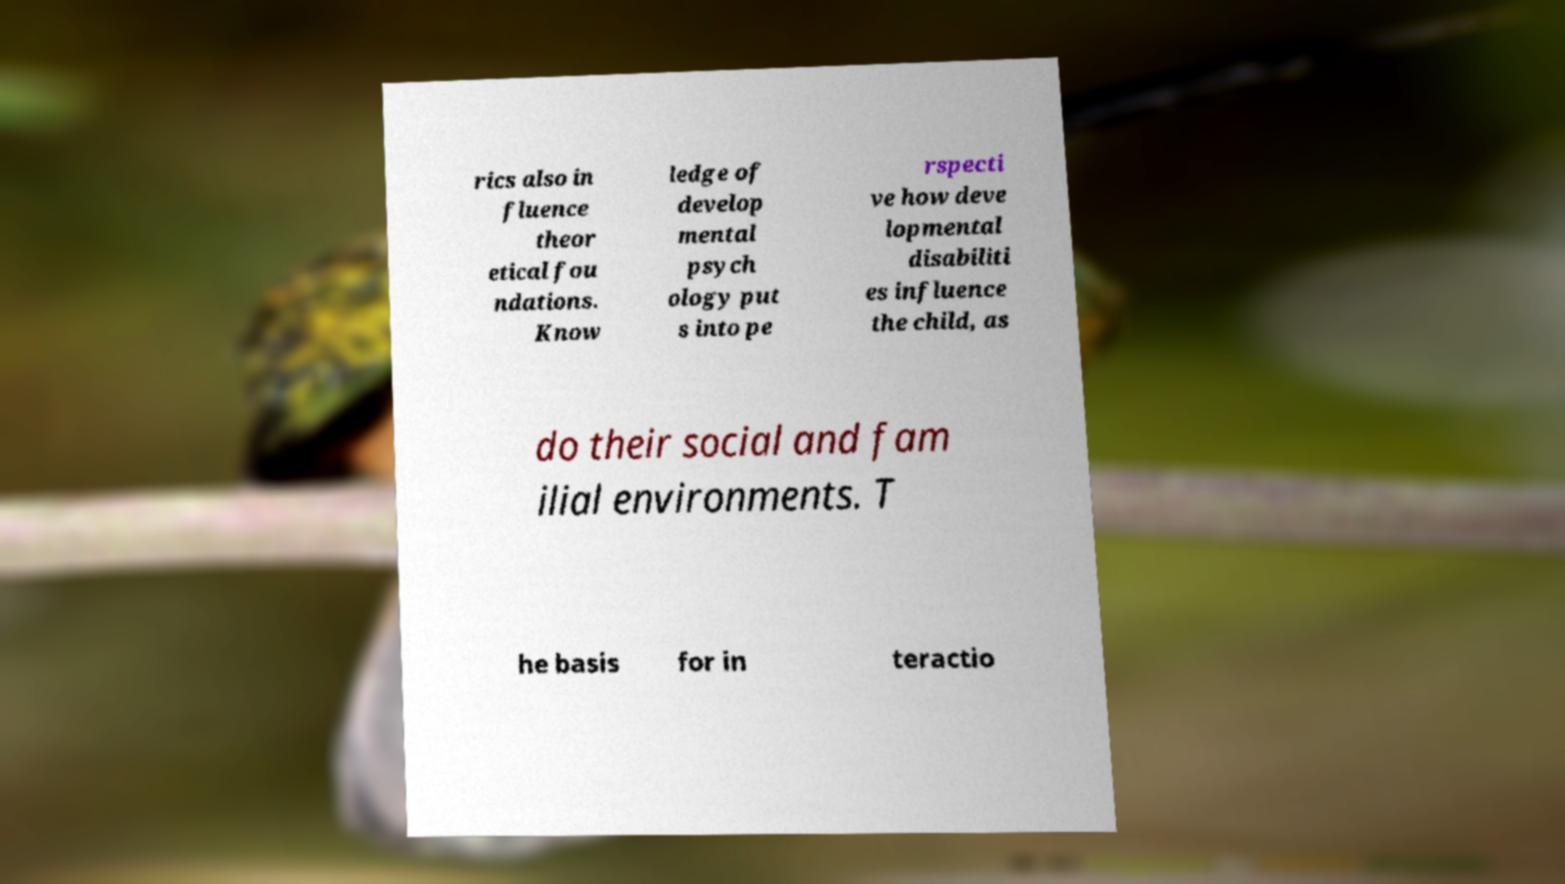There's text embedded in this image that I need extracted. Can you transcribe it verbatim? rics also in fluence theor etical fou ndations. Know ledge of develop mental psych ology put s into pe rspecti ve how deve lopmental disabiliti es influence the child, as do their social and fam ilial environments. T he basis for in teractio 